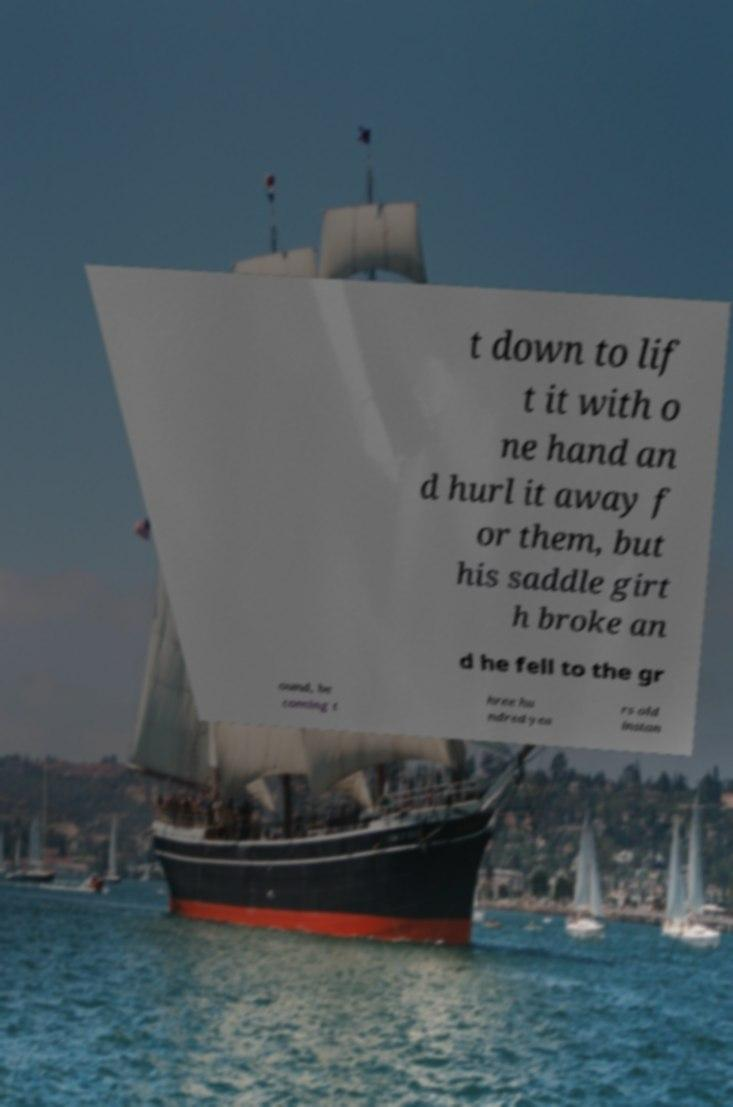Can you read and provide the text displayed in the image?This photo seems to have some interesting text. Can you extract and type it out for me? t down to lif t it with o ne hand an d hurl it away f or them, but his saddle girt h broke an d he fell to the gr ound, be coming t hree hu ndred yea rs old instan 